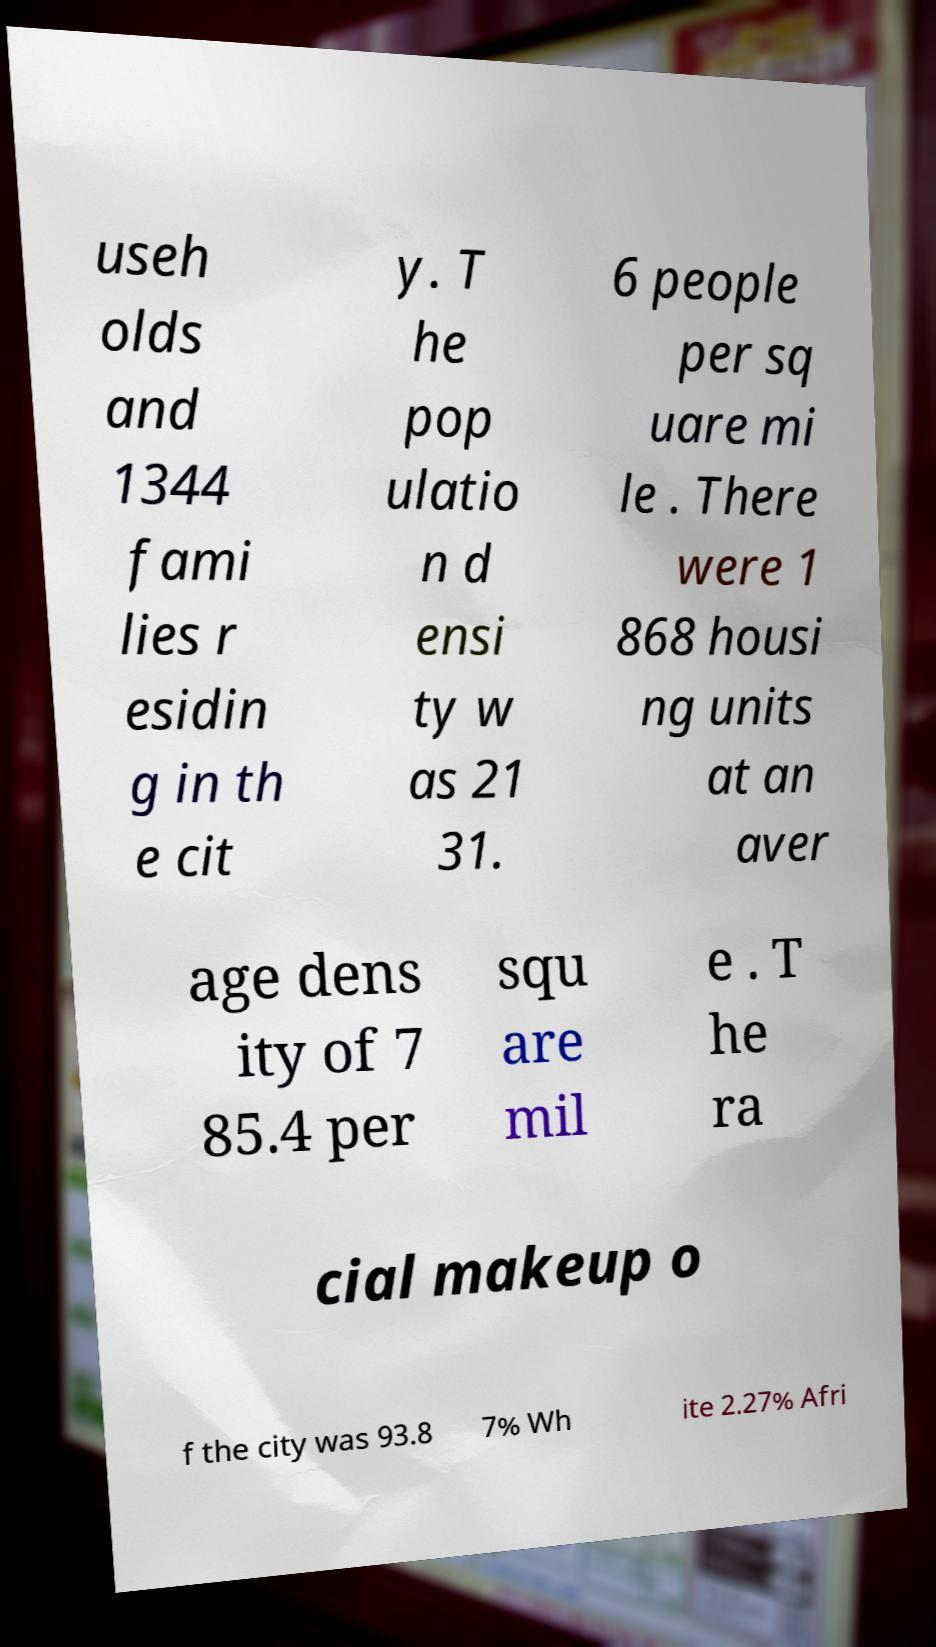What messages or text are displayed in this image? I need them in a readable, typed format. useh olds and 1344 fami lies r esidin g in th e cit y. T he pop ulatio n d ensi ty w as 21 31. 6 people per sq uare mi le . There were 1 868 housi ng units at an aver age dens ity of 7 85.4 per squ are mil e . T he ra cial makeup o f the city was 93.8 7% Wh ite 2.27% Afri 